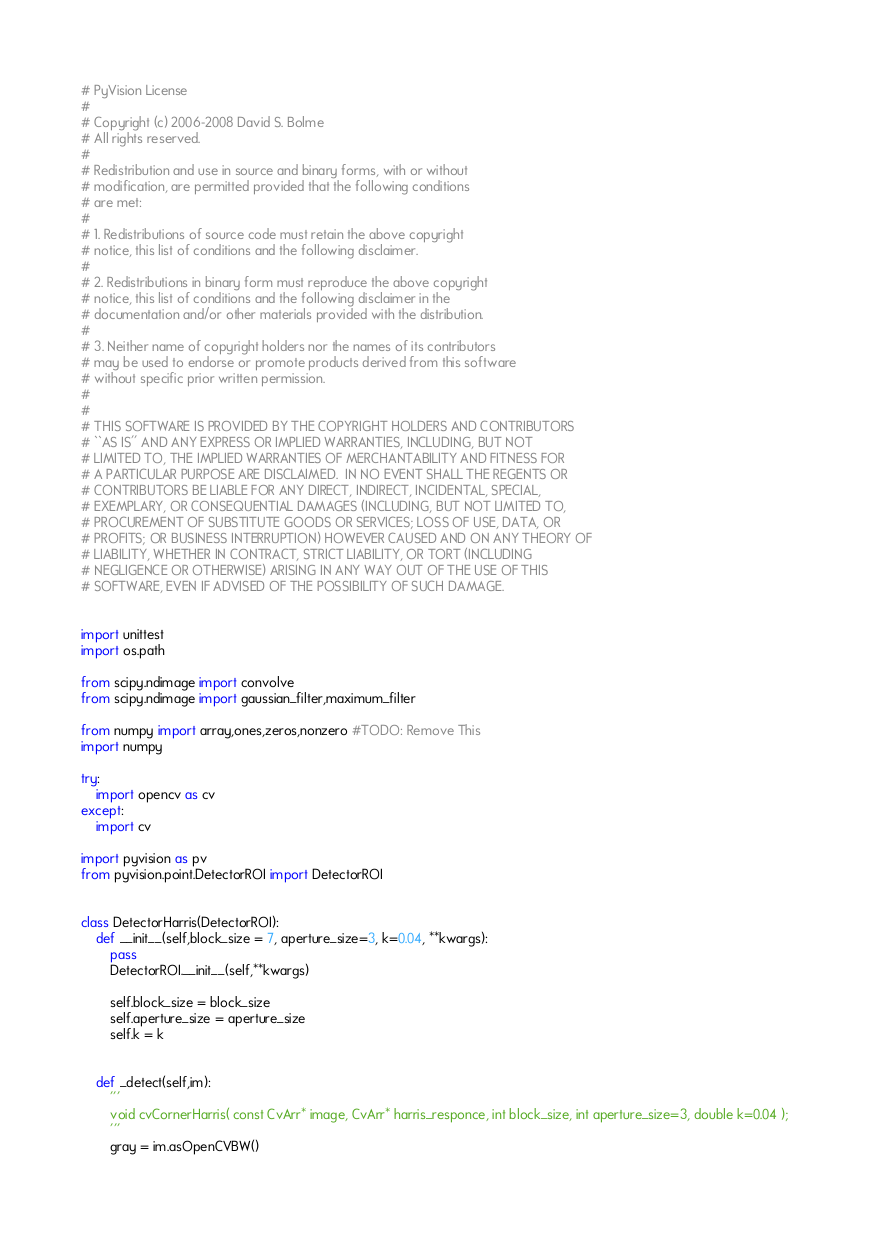<code> <loc_0><loc_0><loc_500><loc_500><_Python_># PyVision License
#
# Copyright (c) 2006-2008 David S. Bolme
# All rights reserved.
#
# Redistribution and use in source and binary forms, with or without
# modification, are permitted provided that the following conditions
# are met:
# 
# 1. Redistributions of source code must retain the above copyright
# notice, this list of conditions and the following disclaimer.
# 
# 2. Redistributions in binary form must reproduce the above copyright
# notice, this list of conditions and the following disclaimer in the
# documentation and/or other materials provided with the distribution.
# 
# 3. Neither name of copyright holders nor the names of its contributors
# may be used to endorse or promote products derived from this software
# without specific prior written permission.
# 
# 
# THIS SOFTWARE IS PROVIDED BY THE COPYRIGHT HOLDERS AND CONTRIBUTORS
# ``AS IS'' AND ANY EXPRESS OR IMPLIED WARRANTIES, INCLUDING, BUT NOT
# LIMITED TO, THE IMPLIED WARRANTIES OF MERCHANTABILITY AND FITNESS FOR
# A PARTICULAR PURPOSE ARE DISCLAIMED.  IN NO EVENT SHALL THE REGENTS OR
# CONTRIBUTORS BE LIABLE FOR ANY DIRECT, INDIRECT, INCIDENTAL, SPECIAL,
# EXEMPLARY, OR CONSEQUENTIAL DAMAGES (INCLUDING, BUT NOT LIMITED TO,
# PROCUREMENT OF SUBSTITUTE GOODS OR SERVICES; LOSS OF USE, DATA, OR
# PROFITS; OR BUSINESS INTERRUPTION) HOWEVER CAUSED AND ON ANY THEORY OF
# LIABILITY, WHETHER IN CONTRACT, STRICT LIABILITY, OR TORT (INCLUDING
# NEGLIGENCE OR OTHERWISE) ARISING IN ANY WAY OUT OF THE USE OF THIS
# SOFTWARE, EVEN IF ADVISED OF THE POSSIBILITY OF SUCH DAMAGE.


import unittest
import os.path

from scipy.ndimage import convolve
from scipy.ndimage import gaussian_filter,maximum_filter

from numpy import array,ones,zeros,nonzero #TODO: Remove This
import numpy

try:
    import opencv as cv
except:
    import cv

import pyvision as pv
from pyvision.point.DetectorROI import DetectorROI


class DetectorHarris(DetectorROI):
    def __init__(self,block_size = 7, aperture_size=3, k=0.04, **kwargs):
        pass
        DetectorROI.__init__(self,**kwargs)
        
        self.block_size = block_size
        self.aperture_size = aperture_size
        self.k = k


    def _detect(self,im):
        '''
        void cvCornerHarris( const CvArr* image, CvArr* harris_responce, int block_size, int aperture_size=3, double k=0.04 );
        '''
        gray = im.asOpenCVBW()</code> 